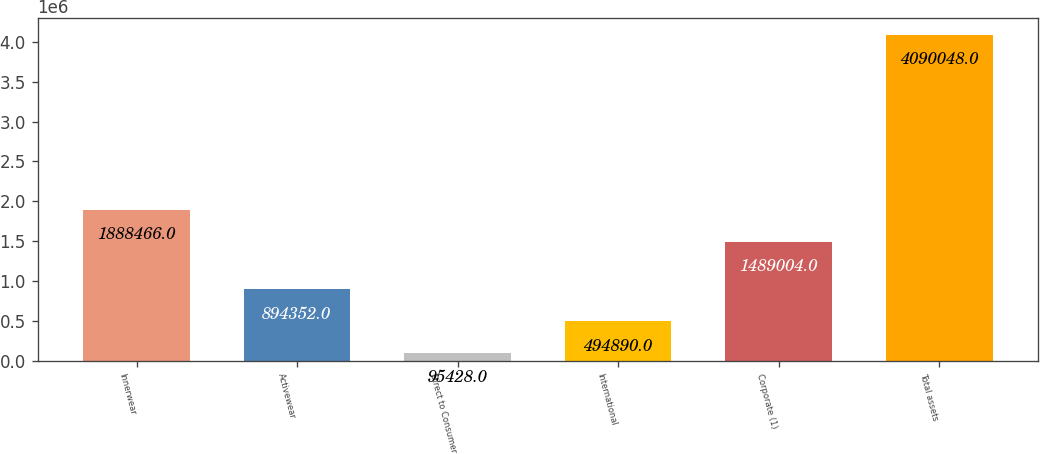Convert chart. <chart><loc_0><loc_0><loc_500><loc_500><bar_chart><fcel>Innerwear<fcel>Activewear<fcel>Direct to Consumer<fcel>International<fcel>Corporate (1)<fcel>Total assets<nl><fcel>1.88847e+06<fcel>894352<fcel>95428<fcel>494890<fcel>1.489e+06<fcel>4.09005e+06<nl></chart> 